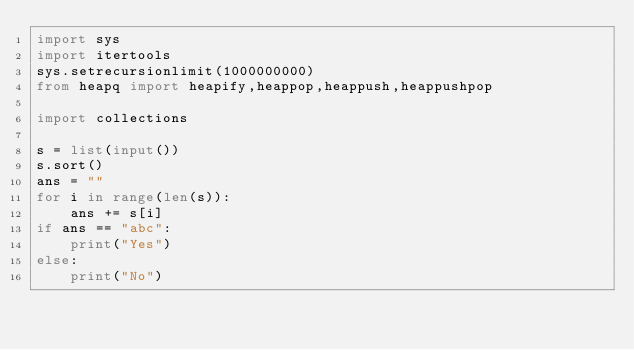<code> <loc_0><loc_0><loc_500><loc_500><_Python_>import sys
import itertools
sys.setrecursionlimit(1000000000)
from heapq import heapify,heappop,heappush,heappushpop

import collections

s = list(input())
s.sort()
ans = ""
for i in range(len(s)):
    ans += s[i]
if ans == "abc":
    print("Yes")
else:
    print("No")</code> 